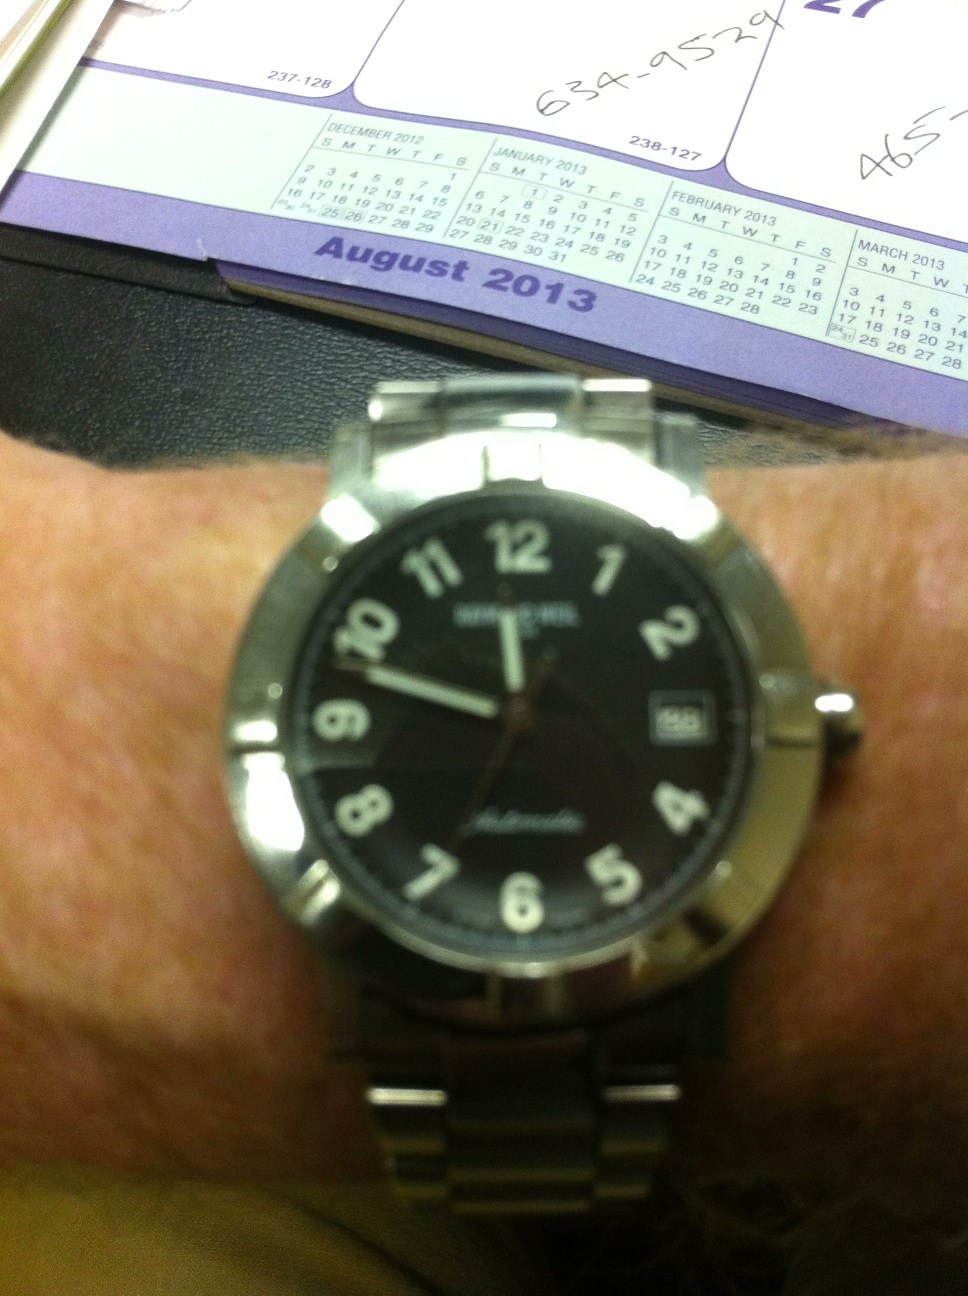Can you tell me more about the type of watch shown in the image? This is a classic men's analogue watch, likely designed for everyday wear. It features a stainless steel bracelet and a black dial which makes it versatile and suitable for both casual and formal attire. The features on the watch, such as large numerals and a date display, emphasize functionality and ease of reading. 